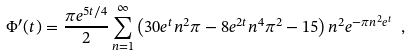<formula> <loc_0><loc_0><loc_500><loc_500>\Phi ^ { \prime } ( t ) = \frac { \pi e ^ { 5 t / 4 } } { 2 } \sum _ { n = 1 } ^ { \infty } \left ( 3 0 e ^ { t } n ^ { 2 } \pi - 8 e ^ { 2 t } n ^ { 4 } \pi ^ { 2 } - 1 5 \right ) n ^ { 2 } e ^ { - \pi n ^ { 2 } e ^ { t } } \ ,</formula> 